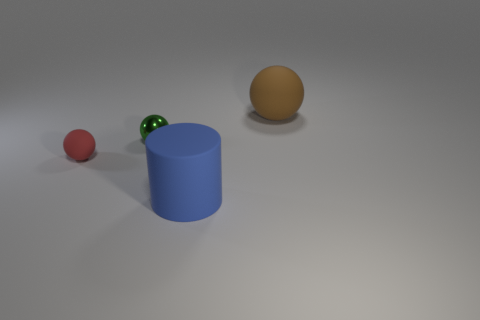Is the color of the small rubber ball the same as the cylinder? No, the small rubber ball appears to be red, while the cylinder is blue. Their colors are distinct from each other. 